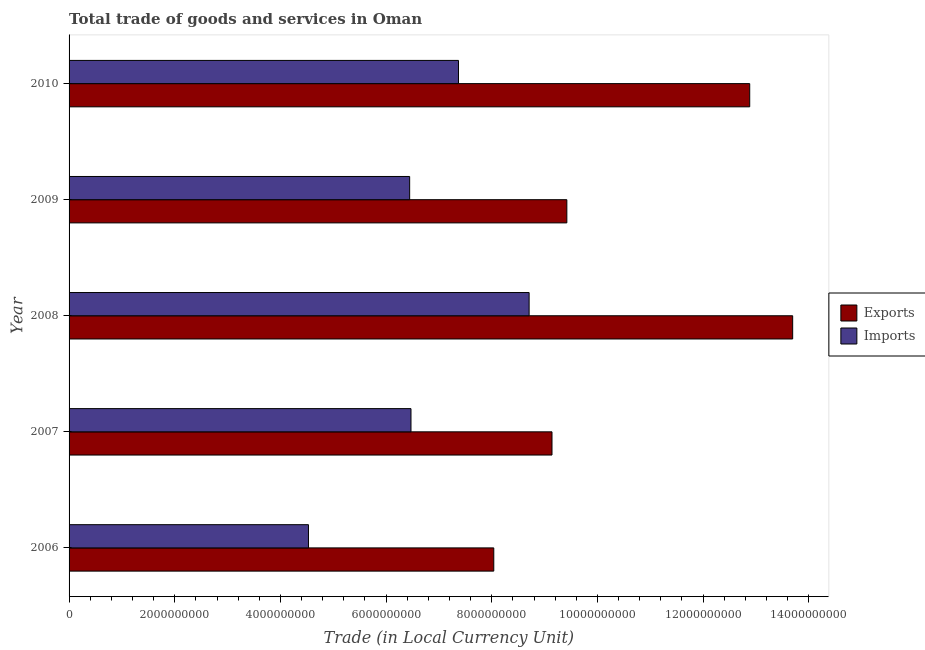How many different coloured bars are there?
Offer a terse response. 2. How many groups of bars are there?
Offer a terse response. 5. In how many cases, is the number of bars for a given year not equal to the number of legend labels?
Provide a succinct answer. 0. What is the imports of goods and services in 2007?
Offer a terse response. 6.47e+09. Across all years, what is the maximum export of goods and services?
Your response must be concise. 1.37e+1. Across all years, what is the minimum export of goods and services?
Offer a very short reply. 8.04e+09. In which year was the export of goods and services minimum?
Offer a terse response. 2006. What is the total export of goods and services in the graph?
Give a very brief answer. 5.32e+1. What is the difference between the export of goods and services in 2008 and that in 2010?
Ensure brevity in your answer.  8.13e+08. What is the difference between the export of goods and services in 2008 and the imports of goods and services in 2009?
Your answer should be compact. 7.25e+09. What is the average imports of goods and services per year?
Ensure brevity in your answer.  6.70e+09. In the year 2009, what is the difference between the imports of goods and services and export of goods and services?
Give a very brief answer. -2.98e+09. In how many years, is the export of goods and services greater than 400000000 LCU?
Your response must be concise. 5. What is the ratio of the export of goods and services in 2006 to that in 2008?
Make the answer very short. 0.59. Is the imports of goods and services in 2008 less than that in 2010?
Keep it short and to the point. No. What is the difference between the highest and the second highest export of goods and services?
Make the answer very short. 8.13e+08. What is the difference between the highest and the lowest imports of goods and services?
Ensure brevity in your answer.  4.18e+09. In how many years, is the imports of goods and services greater than the average imports of goods and services taken over all years?
Offer a terse response. 2. What does the 2nd bar from the top in 2010 represents?
Make the answer very short. Exports. What does the 1st bar from the bottom in 2009 represents?
Give a very brief answer. Exports. Are all the bars in the graph horizontal?
Give a very brief answer. Yes. How many years are there in the graph?
Your answer should be very brief. 5. Does the graph contain grids?
Ensure brevity in your answer.  No. Where does the legend appear in the graph?
Your answer should be compact. Center right. How many legend labels are there?
Your answer should be very brief. 2. How are the legend labels stacked?
Offer a terse response. Vertical. What is the title of the graph?
Provide a short and direct response. Total trade of goods and services in Oman. Does "Secondary school" appear as one of the legend labels in the graph?
Offer a terse response. No. What is the label or title of the X-axis?
Offer a terse response. Trade (in Local Currency Unit). What is the label or title of the Y-axis?
Offer a very short reply. Year. What is the Trade (in Local Currency Unit) in Exports in 2006?
Your answer should be very brief. 8.04e+09. What is the Trade (in Local Currency Unit) in Imports in 2006?
Provide a succinct answer. 4.53e+09. What is the Trade (in Local Currency Unit) in Exports in 2007?
Your answer should be very brief. 9.14e+09. What is the Trade (in Local Currency Unit) in Imports in 2007?
Make the answer very short. 6.47e+09. What is the Trade (in Local Currency Unit) in Exports in 2008?
Provide a succinct answer. 1.37e+1. What is the Trade (in Local Currency Unit) of Imports in 2008?
Your answer should be compact. 8.71e+09. What is the Trade (in Local Currency Unit) in Exports in 2009?
Provide a succinct answer. 9.42e+09. What is the Trade (in Local Currency Unit) in Imports in 2009?
Provide a succinct answer. 6.45e+09. What is the Trade (in Local Currency Unit) of Exports in 2010?
Your answer should be compact. 1.29e+1. What is the Trade (in Local Currency Unit) in Imports in 2010?
Your answer should be very brief. 7.37e+09. Across all years, what is the maximum Trade (in Local Currency Unit) in Exports?
Give a very brief answer. 1.37e+1. Across all years, what is the maximum Trade (in Local Currency Unit) of Imports?
Provide a short and direct response. 8.71e+09. Across all years, what is the minimum Trade (in Local Currency Unit) of Exports?
Provide a succinct answer. 8.04e+09. Across all years, what is the minimum Trade (in Local Currency Unit) in Imports?
Your response must be concise. 4.53e+09. What is the total Trade (in Local Currency Unit) of Exports in the graph?
Provide a short and direct response. 5.32e+1. What is the total Trade (in Local Currency Unit) of Imports in the graph?
Your response must be concise. 3.35e+1. What is the difference between the Trade (in Local Currency Unit) in Exports in 2006 and that in 2007?
Offer a terse response. -1.10e+09. What is the difference between the Trade (in Local Currency Unit) in Imports in 2006 and that in 2007?
Provide a succinct answer. -1.94e+09. What is the difference between the Trade (in Local Currency Unit) in Exports in 2006 and that in 2008?
Provide a succinct answer. -5.66e+09. What is the difference between the Trade (in Local Currency Unit) of Imports in 2006 and that in 2008?
Your response must be concise. -4.18e+09. What is the difference between the Trade (in Local Currency Unit) of Exports in 2006 and that in 2009?
Provide a short and direct response. -1.38e+09. What is the difference between the Trade (in Local Currency Unit) of Imports in 2006 and that in 2009?
Provide a short and direct response. -1.92e+09. What is the difference between the Trade (in Local Currency Unit) of Exports in 2006 and that in 2010?
Offer a very short reply. -4.84e+09. What is the difference between the Trade (in Local Currency Unit) in Imports in 2006 and that in 2010?
Keep it short and to the point. -2.84e+09. What is the difference between the Trade (in Local Currency Unit) of Exports in 2007 and that in 2008?
Provide a short and direct response. -4.56e+09. What is the difference between the Trade (in Local Currency Unit) in Imports in 2007 and that in 2008?
Keep it short and to the point. -2.24e+09. What is the difference between the Trade (in Local Currency Unit) of Exports in 2007 and that in 2009?
Provide a succinct answer. -2.81e+08. What is the difference between the Trade (in Local Currency Unit) of Imports in 2007 and that in 2009?
Ensure brevity in your answer.  2.50e+07. What is the difference between the Trade (in Local Currency Unit) in Exports in 2007 and that in 2010?
Offer a very short reply. -3.74e+09. What is the difference between the Trade (in Local Currency Unit) in Imports in 2007 and that in 2010?
Your answer should be compact. -8.99e+08. What is the difference between the Trade (in Local Currency Unit) in Exports in 2008 and that in 2009?
Your answer should be compact. 4.27e+09. What is the difference between the Trade (in Local Currency Unit) in Imports in 2008 and that in 2009?
Provide a short and direct response. 2.26e+09. What is the difference between the Trade (in Local Currency Unit) of Exports in 2008 and that in 2010?
Offer a very short reply. 8.13e+08. What is the difference between the Trade (in Local Currency Unit) in Imports in 2008 and that in 2010?
Give a very brief answer. 1.34e+09. What is the difference between the Trade (in Local Currency Unit) in Exports in 2009 and that in 2010?
Your response must be concise. -3.46e+09. What is the difference between the Trade (in Local Currency Unit) in Imports in 2009 and that in 2010?
Your response must be concise. -9.24e+08. What is the difference between the Trade (in Local Currency Unit) of Exports in 2006 and the Trade (in Local Currency Unit) of Imports in 2007?
Provide a succinct answer. 1.57e+09. What is the difference between the Trade (in Local Currency Unit) of Exports in 2006 and the Trade (in Local Currency Unit) of Imports in 2008?
Your answer should be compact. -6.69e+08. What is the difference between the Trade (in Local Currency Unit) of Exports in 2006 and the Trade (in Local Currency Unit) of Imports in 2009?
Provide a succinct answer. 1.59e+09. What is the difference between the Trade (in Local Currency Unit) of Exports in 2006 and the Trade (in Local Currency Unit) of Imports in 2010?
Your response must be concise. 6.68e+08. What is the difference between the Trade (in Local Currency Unit) in Exports in 2007 and the Trade (in Local Currency Unit) in Imports in 2008?
Ensure brevity in your answer.  4.33e+08. What is the difference between the Trade (in Local Currency Unit) in Exports in 2007 and the Trade (in Local Currency Unit) in Imports in 2009?
Make the answer very short. 2.69e+09. What is the difference between the Trade (in Local Currency Unit) of Exports in 2007 and the Trade (in Local Currency Unit) of Imports in 2010?
Your answer should be compact. 1.77e+09. What is the difference between the Trade (in Local Currency Unit) of Exports in 2008 and the Trade (in Local Currency Unit) of Imports in 2009?
Give a very brief answer. 7.25e+09. What is the difference between the Trade (in Local Currency Unit) in Exports in 2008 and the Trade (in Local Currency Unit) in Imports in 2010?
Offer a very short reply. 6.32e+09. What is the difference between the Trade (in Local Currency Unit) in Exports in 2009 and the Trade (in Local Currency Unit) in Imports in 2010?
Your answer should be compact. 2.05e+09. What is the average Trade (in Local Currency Unit) of Exports per year?
Offer a very short reply. 1.06e+1. What is the average Trade (in Local Currency Unit) of Imports per year?
Offer a terse response. 6.70e+09. In the year 2006, what is the difference between the Trade (in Local Currency Unit) in Exports and Trade (in Local Currency Unit) in Imports?
Your answer should be compact. 3.51e+09. In the year 2007, what is the difference between the Trade (in Local Currency Unit) in Exports and Trade (in Local Currency Unit) in Imports?
Ensure brevity in your answer.  2.67e+09. In the year 2008, what is the difference between the Trade (in Local Currency Unit) in Exports and Trade (in Local Currency Unit) in Imports?
Offer a terse response. 4.99e+09. In the year 2009, what is the difference between the Trade (in Local Currency Unit) of Exports and Trade (in Local Currency Unit) of Imports?
Provide a succinct answer. 2.98e+09. In the year 2010, what is the difference between the Trade (in Local Currency Unit) of Exports and Trade (in Local Currency Unit) of Imports?
Make the answer very short. 5.51e+09. What is the ratio of the Trade (in Local Currency Unit) in Exports in 2006 to that in 2007?
Give a very brief answer. 0.88. What is the ratio of the Trade (in Local Currency Unit) of Imports in 2006 to that in 2007?
Your response must be concise. 0.7. What is the ratio of the Trade (in Local Currency Unit) of Exports in 2006 to that in 2008?
Provide a succinct answer. 0.59. What is the ratio of the Trade (in Local Currency Unit) of Imports in 2006 to that in 2008?
Your answer should be compact. 0.52. What is the ratio of the Trade (in Local Currency Unit) in Exports in 2006 to that in 2009?
Make the answer very short. 0.85. What is the ratio of the Trade (in Local Currency Unit) in Imports in 2006 to that in 2009?
Offer a terse response. 0.7. What is the ratio of the Trade (in Local Currency Unit) of Exports in 2006 to that in 2010?
Keep it short and to the point. 0.62. What is the ratio of the Trade (in Local Currency Unit) in Imports in 2006 to that in 2010?
Your response must be concise. 0.61. What is the ratio of the Trade (in Local Currency Unit) in Exports in 2007 to that in 2008?
Your answer should be very brief. 0.67. What is the ratio of the Trade (in Local Currency Unit) of Imports in 2007 to that in 2008?
Your answer should be compact. 0.74. What is the ratio of the Trade (in Local Currency Unit) in Exports in 2007 to that in 2009?
Make the answer very short. 0.97. What is the ratio of the Trade (in Local Currency Unit) in Exports in 2007 to that in 2010?
Provide a succinct answer. 0.71. What is the ratio of the Trade (in Local Currency Unit) in Imports in 2007 to that in 2010?
Give a very brief answer. 0.88. What is the ratio of the Trade (in Local Currency Unit) of Exports in 2008 to that in 2009?
Offer a terse response. 1.45. What is the ratio of the Trade (in Local Currency Unit) in Imports in 2008 to that in 2009?
Your response must be concise. 1.35. What is the ratio of the Trade (in Local Currency Unit) of Exports in 2008 to that in 2010?
Your answer should be compact. 1.06. What is the ratio of the Trade (in Local Currency Unit) in Imports in 2008 to that in 2010?
Make the answer very short. 1.18. What is the ratio of the Trade (in Local Currency Unit) in Exports in 2009 to that in 2010?
Your answer should be very brief. 0.73. What is the ratio of the Trade (in Local Currency Unit) of Imports in 2009 to that in 2010?
Your answer should be compact. 0.87. What is the difference between the highest and the second highest Trade (in Local Currency Unit) of Exports?
Provide a succinct answer. 8.13e+08. What is the difference between the highest and the second highest Trade (in Local Currency Unit) of Imports?
Keep it short and to the point. 1.34e+09. What is the difference between the highest and the lowest Trade (in Local Currency Unit) in Exports?
Offer a very short reply. 5.66e+09. What is the difference between the highest and the lowest Trade (in Local Currency Unit) in Imports?
Provide a short and direct response. 4.18e+09. 